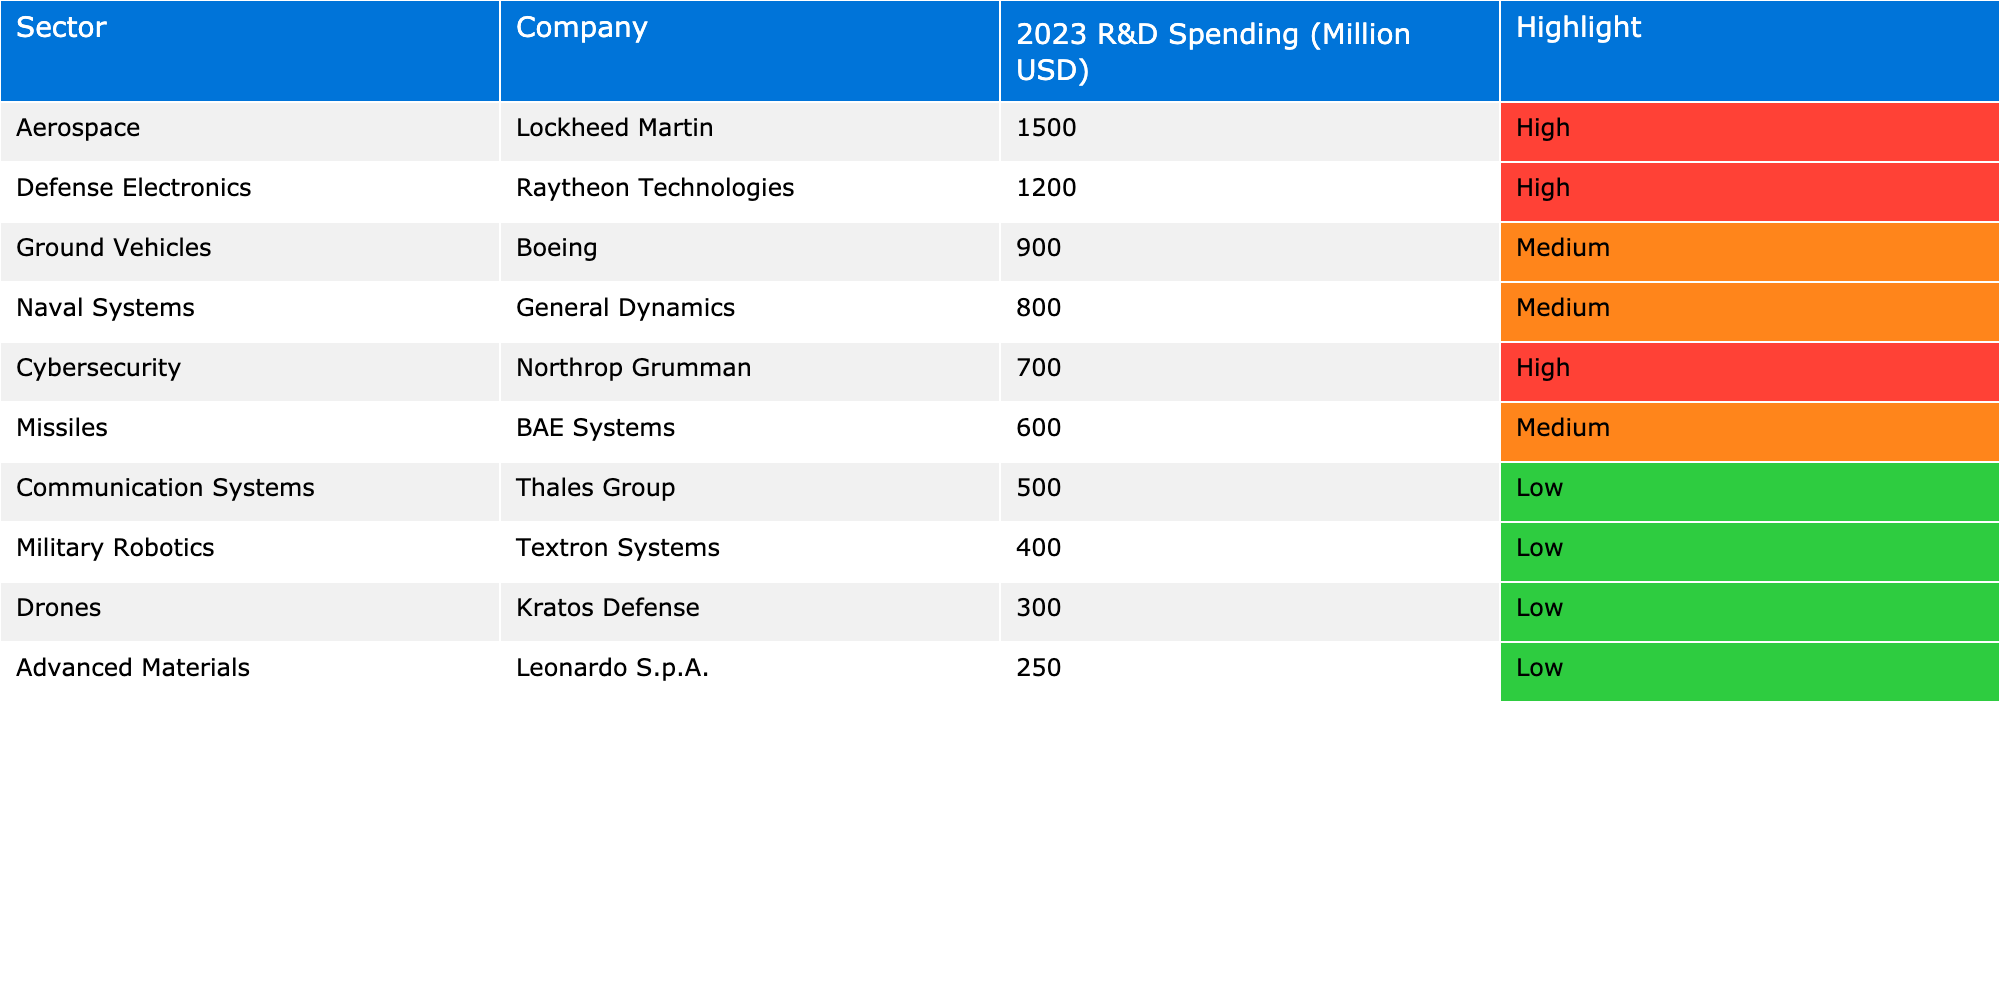What is the highest R&D spending in the table? Lockheed Martin has the highest R&D spending with 1500 million USD, as indicated in the "2023 R&D Spending (Million USD)" column.
Answer: 1500 million USD Which sector has the lowest R&D spending? The "Drones" sector, represented by Kratos Defense, has the lowest R&D spending at 300 million USD in the table.
Answer: Drones How much more does Raytheon Technologies spend on R&D than Boeing? Raytheon Technologies spends 1200 million USD, while Boeing spends 900 million USD. The difference is calculated as 1200 - 900 = 300 million USD.
Answer: 300 million USD Which sectors are highlighted as 'High'? The sectors highlighted as 'High' in the table are Aerospace (Lockheed Martin), Defense Electronics (Raytheon Technologies), and Cybersecurity (Northrop Grumman).
Answer: Aerospace, Defense Electronics, Cybersecurity What is the total R&D spending for all sectors in the table? Summing up all spending: 1500 + 1200 + 900 + 800 + 700 + 600 + 500 + 400 + 300 + 250 = 6150 million USD gives the total spending in the table.
Answer: 6150 million USD Does any company from the Cybersecurity sector have the same spending as any company from the Ground Vehicles sector? Northrop Grumman in the Cybersecurity sector has 700 million USD, and Boeing in the Ground Vehicles sector has 900 million USD. Since 700 does not equal 900, they do not match.
Answer: No What is the average R&D spending for sectors with 'Medium' highlight? The sectors with 'Medium' highlight are Ground Vehicles (900 million), Naval Systems (800 million), and Missiles (600 million). The average is calculated as (900 + 800 + 600) / 3 = 766.67 million USD.
Answer: 766.67 million USD Which company spends more: BAE Systems or Northrop Grumman? BAE Systems spends 600 million USD on R&D while Northrop Grumman spends 700 million USD. Therefore, Northrop Grumman spends more than BAE Systems.
Answer: Northrop Grumman If you combine the spending of all 'Low' highlighted sectors, what is the total? The 'Low' highlighted sectors are Communication Systems (500 million), Military Robotics (400 million), Drones (300 million), and Advanced Materials (250 million). Their total is 500 + 400 + 300 + 250 = 1450 million USD.
Answer: 1450 million USD Is there any sector where more than 1000 million USD is spent? Yes, the Aerospace sector (Lockheed Martin) and Defense Electronics sector (Raytheon Technologies) both have spending that exceeds 1000 million USD, with values of 1500 and 1200 million USD, respectively.
Answer: Yes 